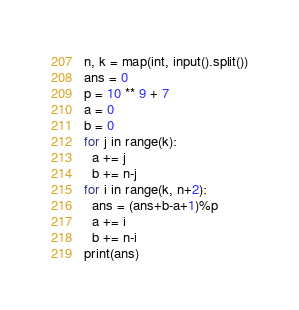Convert code to text. <code><loc_0><loc_0><loc_500><loc_500><_Python_>n, k = map(int, input().split())
ans = 0
p = 10 ** 9 + 7
a = 0
b = 0
for j in range(k):
  a += j
  b += n-j
for i in range(k, n+2):
  ans = (ans+b-a+1)%p
  a += i
  b += n-i
print(ans)</code> 